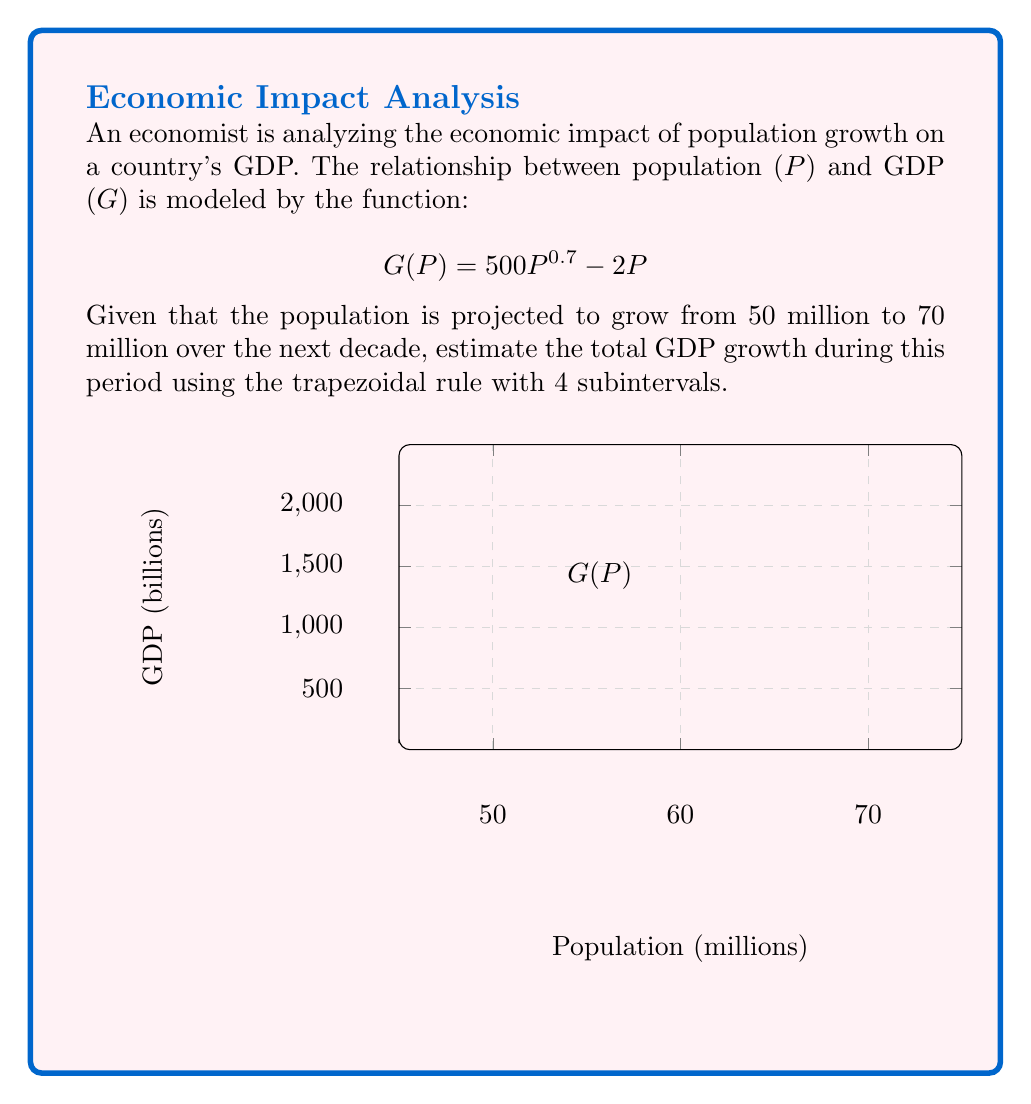Can you solve this math problem? To solve this problem, we'll follow these steps:

1) The trapezoidal rule for numerical integration is given by:

   $$\int_{a}^{b} f(x) dx \approx \frac{h}{2}[f(x_0) + 2f(x_1) + 2f(x_2) + ... + 2f(x_{n-1}) + f(x_n)]$$

   where $h = \frac{b-a}{n}$, and $n$ is the number of subintervals.

2) In our case:
   $a = 50$ (million), $b = 70$ (million), $n = 4$

3) Calculate $h$:
   $h = \frac{70-50}{4} = 5$ (million)

4) Calculate the x-values:
   $x_0 = 50$, $x_1 = 55$, $x_2 = 60$, $x_3 = 65$, $x_4 = 70$

5) Calculate G(P) for each x-value:
   $G(50) = 500(50^{0.7}) - 2(50) = 7394.43$
   $G(55) = 500(55^{0.7}) - 2(55) = 7979.69$
   $G(60) = 500(60^{0.7}) - 2(60) = 8553.49$
   $G(65) = 500(65^{0.7}) - 2(65) = 9116.59$
   $G(70) = 500(70^{0.7}) - 2(70) = 9669.54$

6) Apply the trapezoidal rule:
   $$\text{GDP Growth} \approx \frac{5}{2}[7394.43 + 2(7979.69) + 2(8553.49) + 2(9116.59) + 9669.54]$$
   $$= 2.5[7394.43 + 15959.38 + 17106.98 + 18233.18 + 9669.54]$$
   $$= 2.5(68363.51) = 170908.775$$

Therefore, the estimated total GDP growth over the decade is approximately 170,909 billion currency units.
Answer: 170,909 billion currency units 